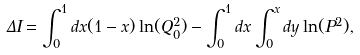<formula> <loc_0><loc_0><loc_500><loc_500>\Delta I = \int _ { 0 } ^ { 1 } d x ( 1 - x ) \ln ( Q _ { 0 } ^ { 2 } ) - \int _ { 0 } ^ { 1 } d x \int _ { 0 } ^ { x } d y \ln ( P ^ { 2 } ) ,</formula> 